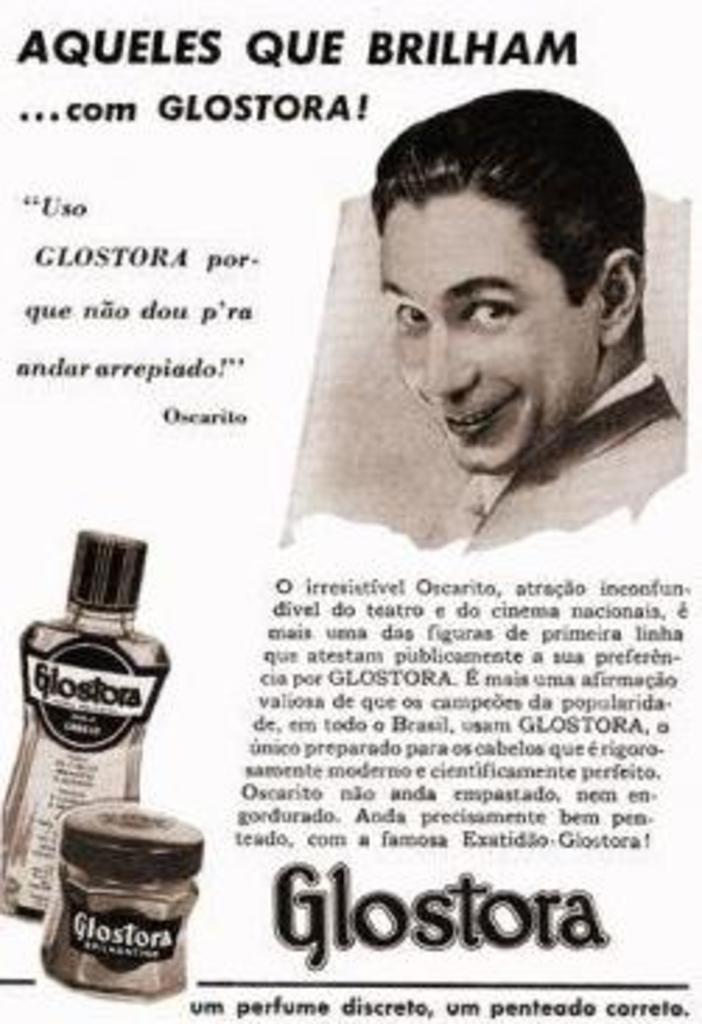<image>
Give a short and clear explanation of the subsequent image. An ad for the product Glostora in another language. 